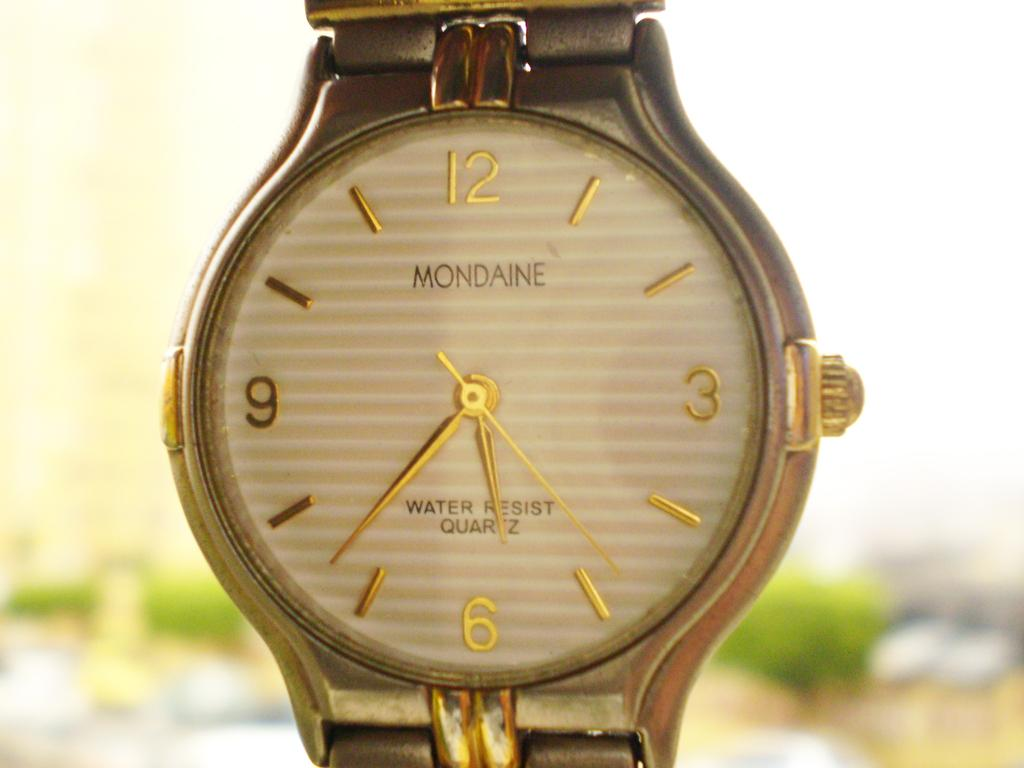Provide a one-sentence caption for the provided image. A golden Mondaine watch with the time 6:35. 